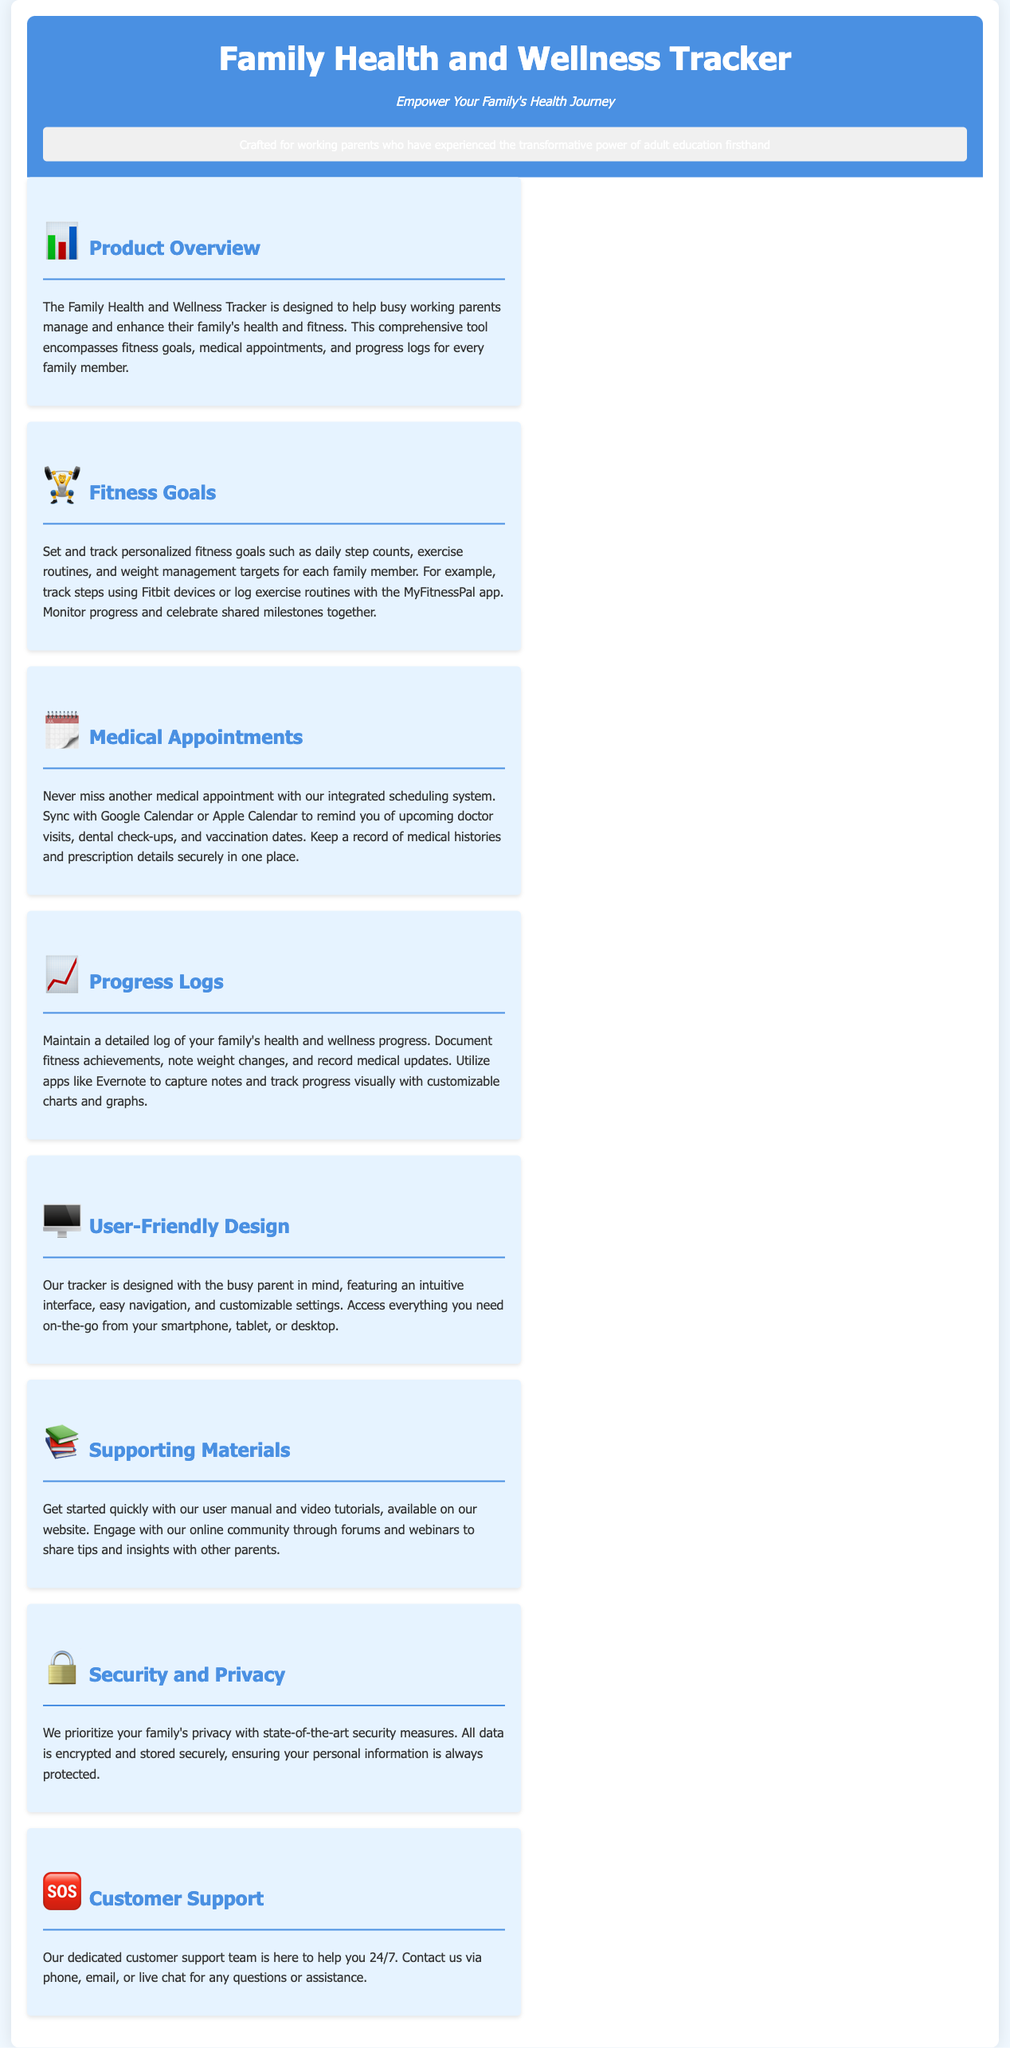what is the title of the product? The title of the product is found in the header section of the document.
Answer: Family Health and Wellness Tracker who is the target audience? The target audience is described in the persona section of the document.
Answer: working parents what features can be tracked? The document lists multiple features that can be tracked by the product.
Answer: fitness goals, medical appointments, and progress logs how can medical appointments be scheduled? The document mentions how medical appointments can be managed through the integration.
Answer: Sync with Google Calendar or Apple Calendar what is emphasized about data security? The document specifically outlines the approach to security and privacy of user data.
Answer: state-of-the-art security measures how can users access the tracker? The document explains the different ways users can interact with the tracker.
Answer: smartphone, tablet, or desktop what type of support is provided? The document describes the availability of assistance for users.
Answer: 24/7 customer support what does the product promote for family health? The product's core aim is highlighted within the overview section.
Answer: manage and enhance family's health and fitness 